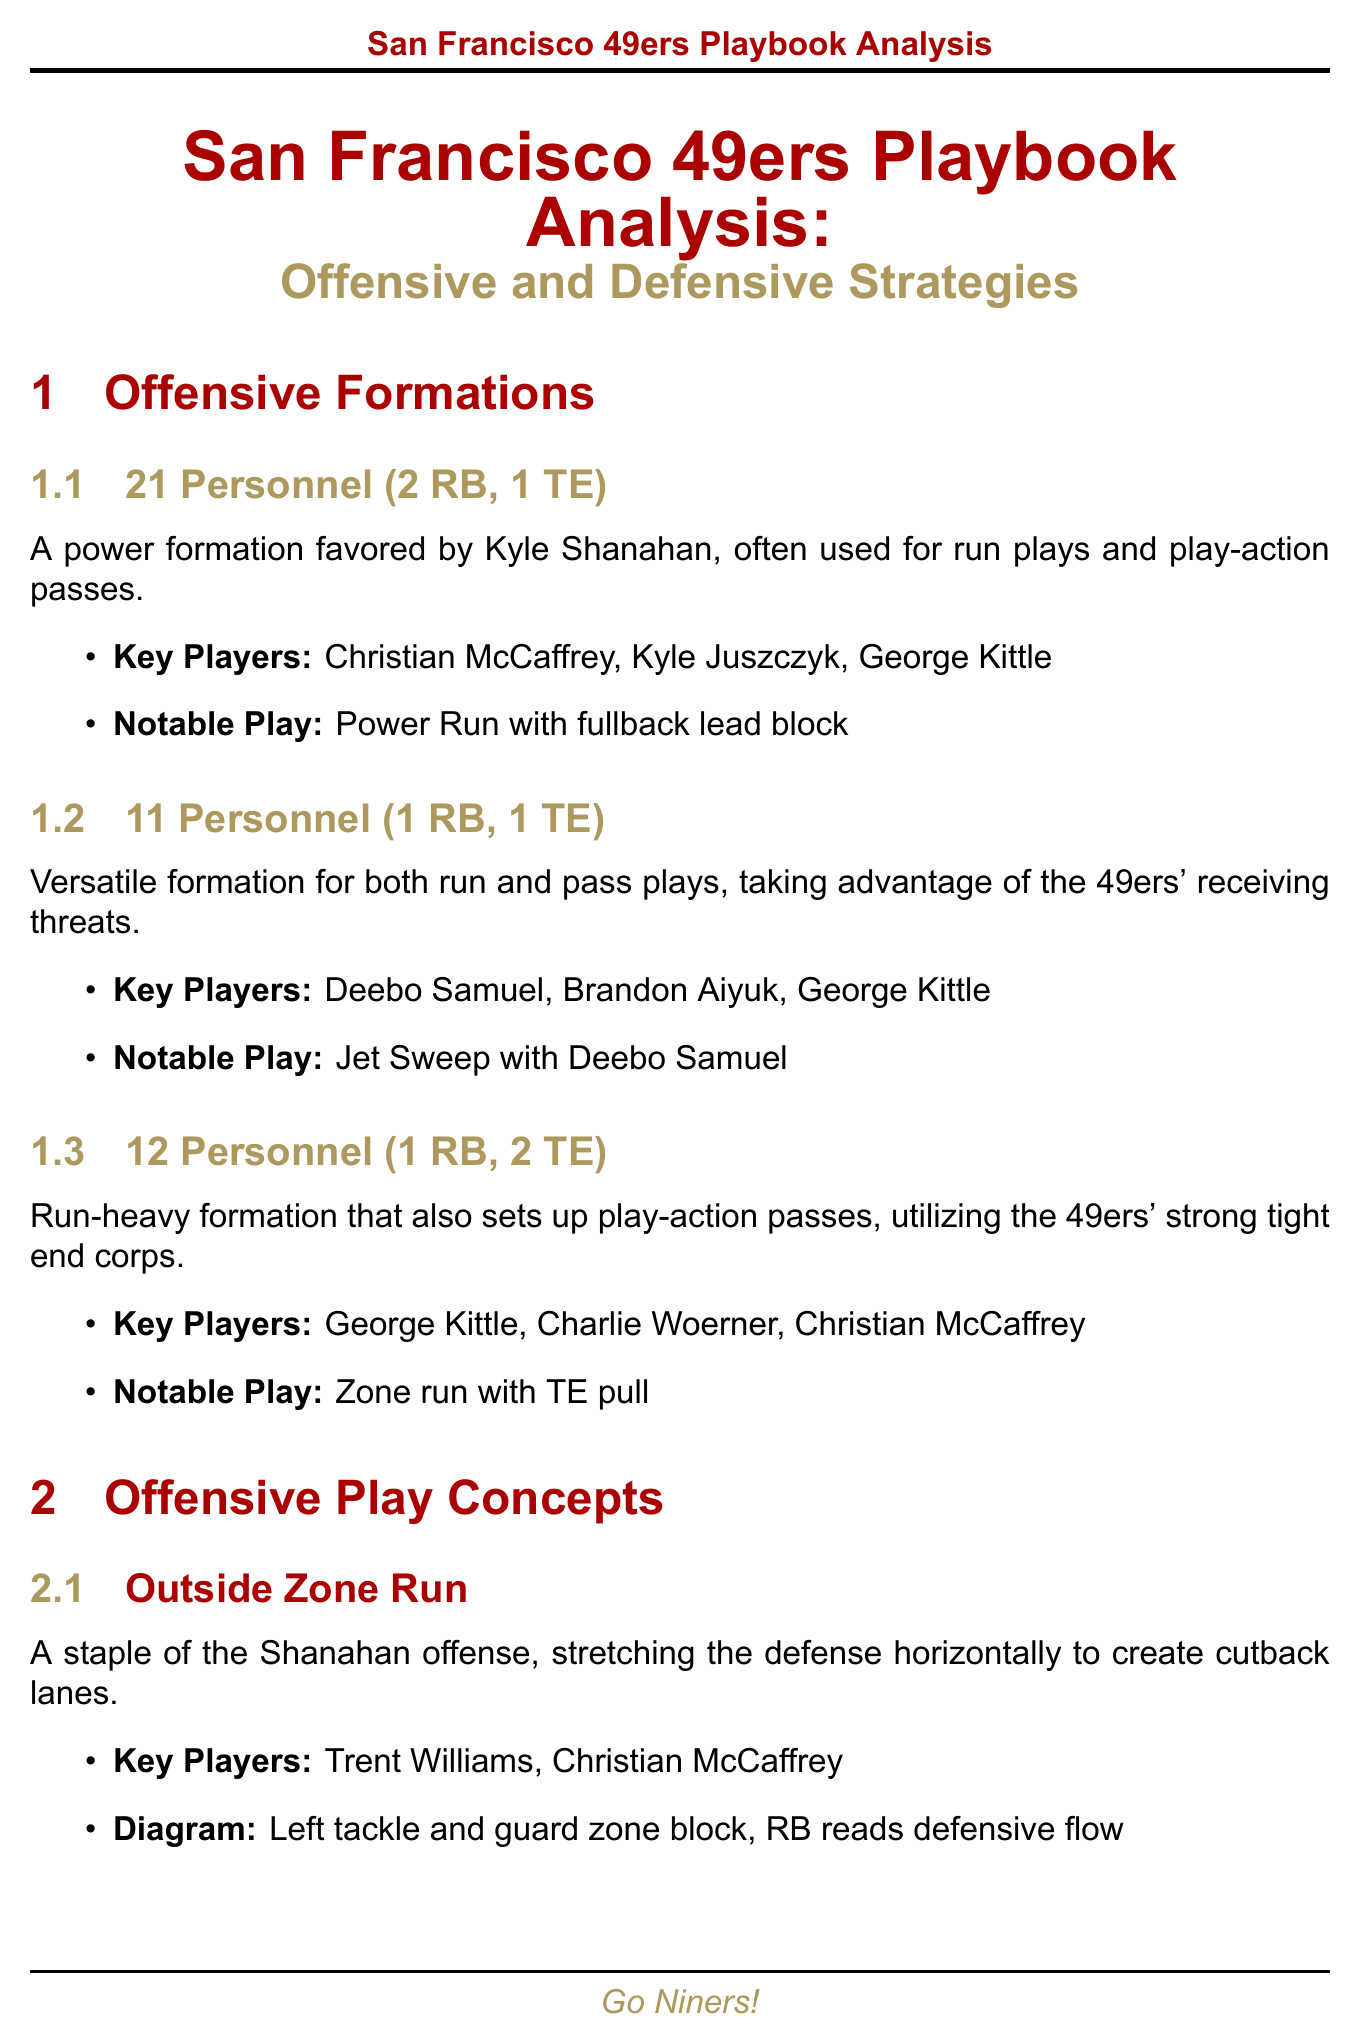What is the title of the document? The title is prominently displayed at the beginning of the document, introducing the main topic covered.
Answer: San Francisco 49ers Playbook Analysis: Offensive and Defensive Strategies Name a key player in the 21 Personnel formation. The document lists key players associated with each formation, and it specifies them under the Offensive Formations section.
Answer: Christian McCaffrey What is the notable play for the 11 Personnel formation? The notable play for this formation is mentioned directly in the description of the 11 Personnel section.
Answer: Jet Sweep with Deebo Samuel Which defensive formation uses a 4-2-5 alignment? The defensive formations are described in their own section, where each alignment and its characteristics are outlined clearly.
Answer: Nickel What concept emphasizes stretching the defense horizontally? The document describes each play concept, including the one that stretches the defense, which is highlighted for its strategic importance.
Answer: Outside Zone Run Who is the key player for the kick return strategy? The specific player responsible for kick returns is identified in the Special Teams Strategies section detailing their responsibilities.
Answer: Ray-Ray McCloud III What is a key takeaway regarding the 49ers' offensive strategy? The conclusion section summarizes key points about the playbook, offering insights into the overarching strategies employed by the team.
Answer: Offensive versatility with multiple personnel packages What is the strength of the 4-3 Under defensive formation? The strengths of each formation are articulated in their respective sections, highlighting their capabilities within the game.
Answer: Strong against the run, creates one-on-one matchups for edge rushers 